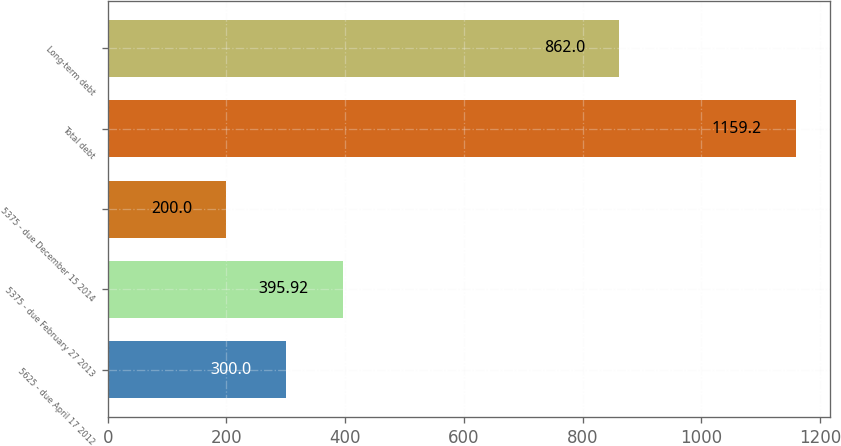Convert chart. <chart><loc_0><loc_0><loc_500><loc_500><bar_chart><fcel>5625 - due April 17 2012<fcel>5375 - due February 27 2013<fcel>5375 - due December 15 2014<fcel>Total debt<fcel>Long-term debt<nl><fcel>300<fcel>395.92<fcel>200<fcel>1159.2<fcel>862<nl></chart> 